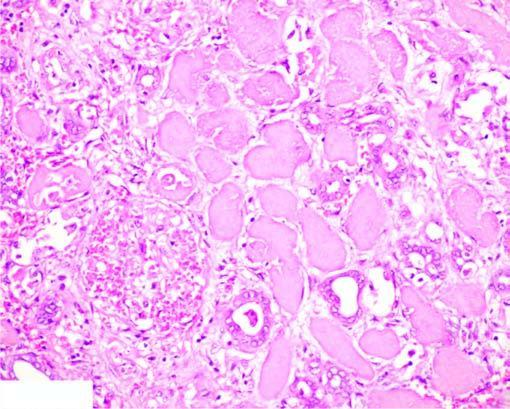what does the interface between viable and non-viable area show?
Answer the question using a single word or phrase. Non-specific chronic inflammation proliferating vessels 